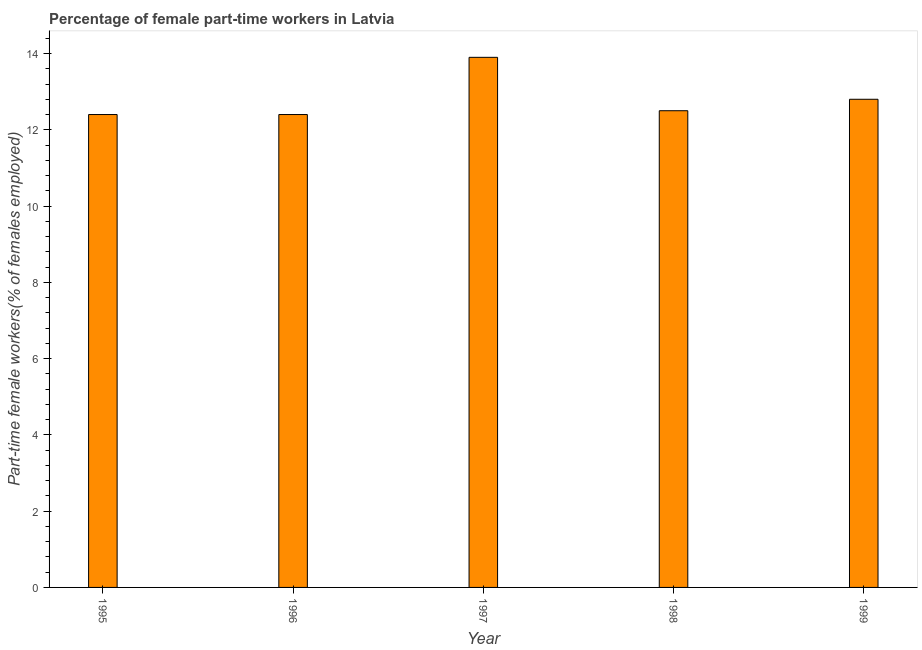What is the title of the graph?
Provide a short and direct response. Percentage of female part-time workers in Latvia. What is the label or title of the Y-axis?
Give a very brief answer. Part-time female workers(% of females employed). What is the percentage of part-time female workers in 1995?
Your answer should be compact. 12.4. Across all years, what is the maximum percentage of part-time female workers?
Make the answer very short. 13.9. Across all years, what is the minimum percentage of part-time female workers?
Ensure brevity in your answer.  12.4. In which year was the percentage of part-time female workers minimum?
Your answer should be compact. 1995. What is the sum of the percentage of part-time female workers?
Your response must be concise. 64. What is the average percentage of part-time female workers per year?
Offer a very short reply. 12.8. In how many years, is the percentage of part-time female workers greater than 4.4 %?
Your answer should be compact. 5. What is the ratio of the percentage of part-time female workers in 1996 to that in 1999?
Give a very brief answer. 0.97. Is the percentage of part-time female workers in 1995 less than that in 1999?
Your response must be concise. Yes. Is the sum of the percentage of part-time female workers in 1997 and 1999 greater than the maximum percentage of part-time female workers across all years?
Your response must be concise. Yes. What is the difference between the highest and the lowest percentage of part-time female workers?
Provide a short and direct response. 1.5. How many bars are there?
Offer a very short reply. 5. Are all the bars in the graph horizontal?
Offer a terse response. No. How many years are there in the graph?
Give a very brief answer. 5. What is the difference between two consecutive major ticks on the Y-axis?
Your answer should be compact. 2. Are the values on the major ticks of Y-axis written in scientific E-notation?
Your answer should be compact. No. What is the Part-time female workers(% of females employed) of 1995?
Your answer should be very brief. 12.4. What is the Part-time female workers(% of females employed) of 1996?
Ensure brevity in your answer.  12.4. What is the Part-time female workers(% of females employed) in 1997?
Make the answer very short. 13.9. What is the Part-time female workers(% of females employed) of 1999?
Keep it short and to the point. 12.8. What is the difference between the Part-time female workers(% of females employed) in 1995 and 1999?
Your response must be concise. -0.4. What is the difference between the Part-time female workers(% of females employed) in 1996 and 1998?
Provide a short and direct response. -0.1. What is the difference between the Part-time female workers(% of females employed) in 1997 and 1998?
Make the answer very short. 1.4. What is the difference between the Part-time female workers(% of females employed) in 1997 and 1999?
Keep it short and to the point. 1.1. What is the ratio of the Part-time female workers(% of females employed) in 1995 to that in 1996?
Your response must be concise. 1. What is the ratio of the Part-time female workers(% of females employed) in 1995 to that in 1997?
Provide a short and direct response. 0.89. What is the ratio of the Part-time female workers(% of females employed) in 1995 to that in 1998?
Offer a very short reply. 0.99. What is the ratio of the Part-time female workers(% of females employed) in 1996 to that in 1997?
Your answer should be very brief. 0.89. What is the ratio of the Part-time female workers(% of females employed) in 1996 to that in 1999?
Offer a terse response. 0.97. What is the ratio of the Part-time female workers(% of females employed) in 1997 to that in 1998?
Your answer should be compact. 1.11. What is the ratio of the Part-time female workers(% of females employed) in 1997 to that in 1999?
Provide a succinct answer. 1.09. What is the ratio of the Part-time female workers(% of females employed) in 1998 to that in 1999?
Your answer should be very brief. 0.98. 